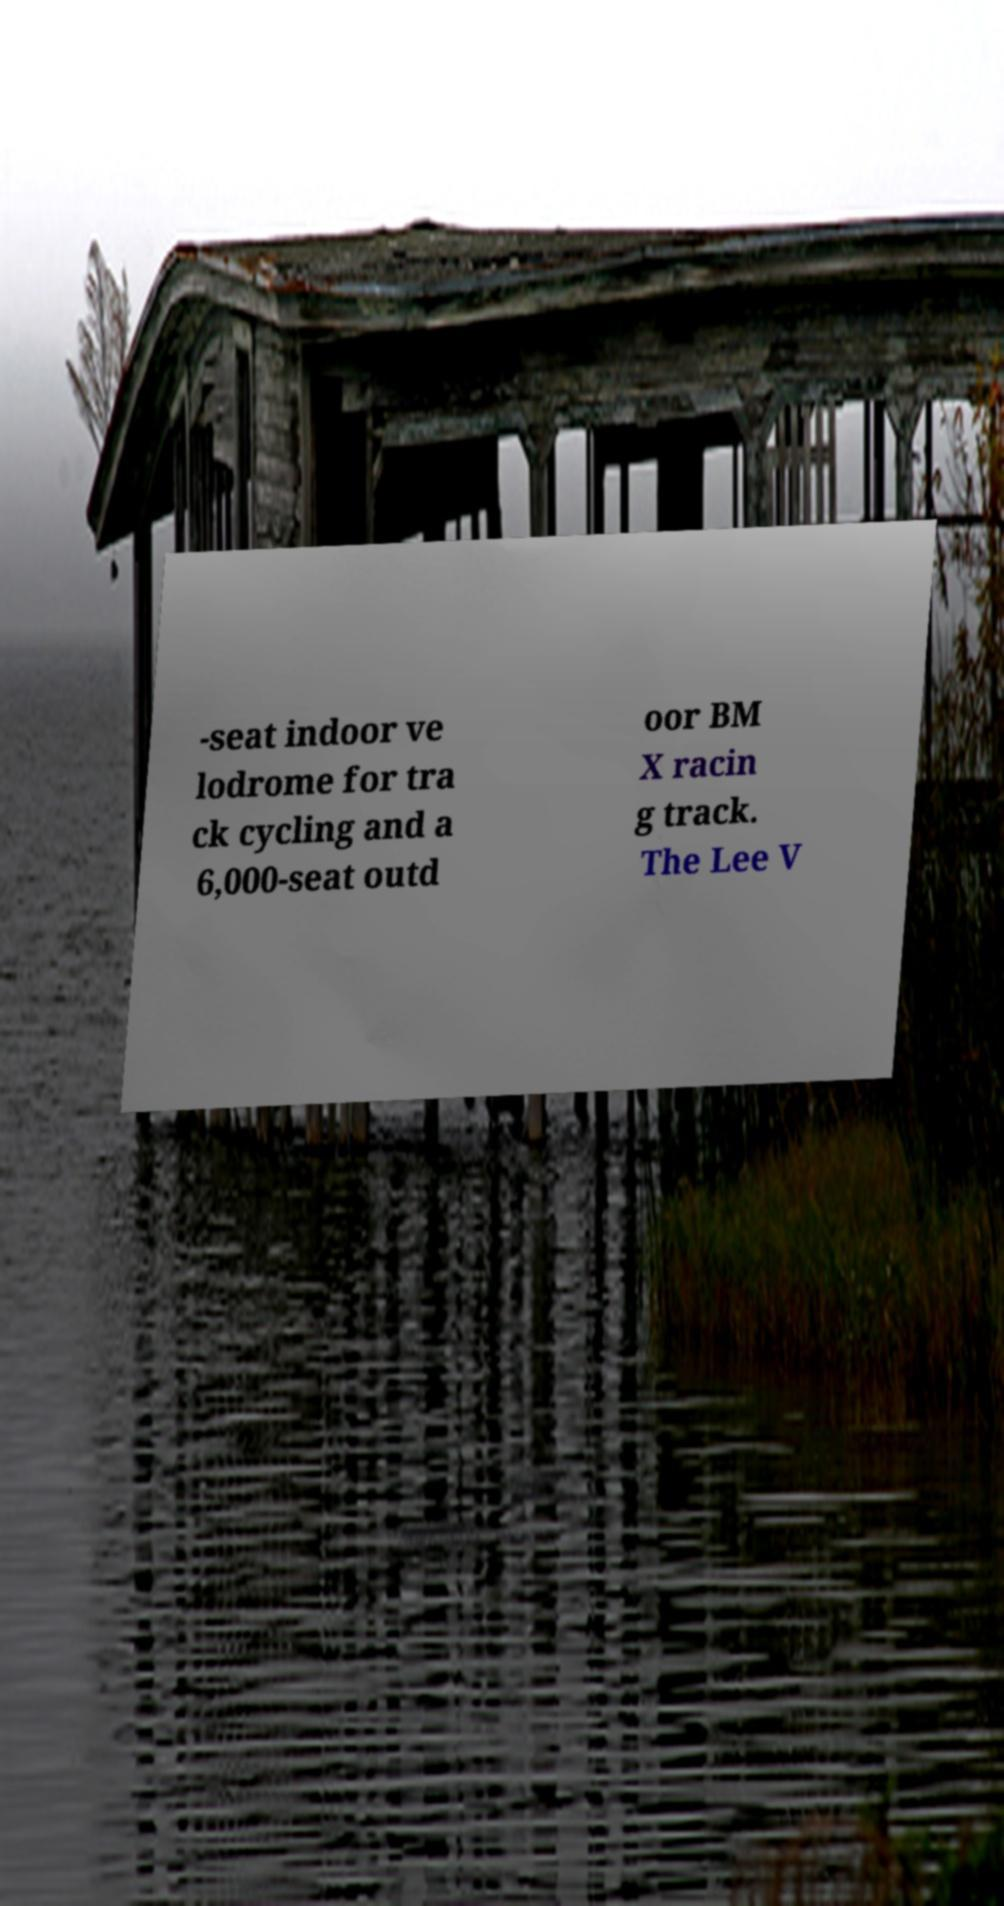Can you accurately transcribe the text from the provided image for me? -seat indoor ve lodrome for tra ck cycling and a 6,000-seat outd oor BM X racin g track. The Lee V 